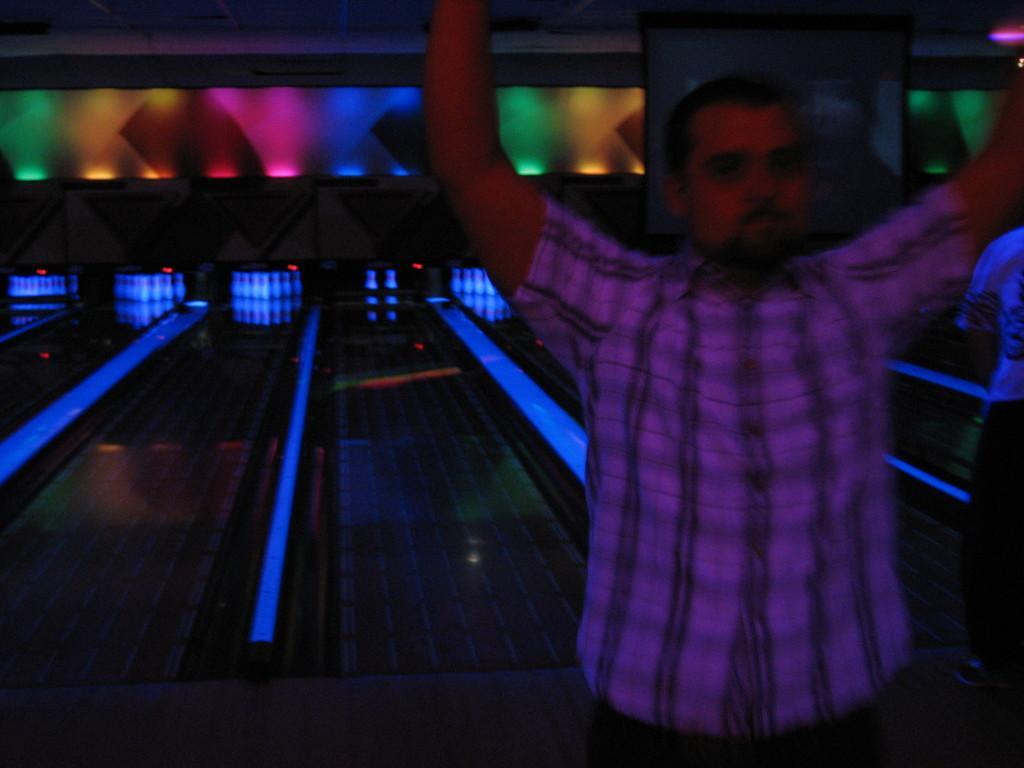Could you give a brief overview of what you see in this image? In the foreground of the picture we can see a person cheering. In the background we can see a bowling platform and light. At the top it looks like a wall. 